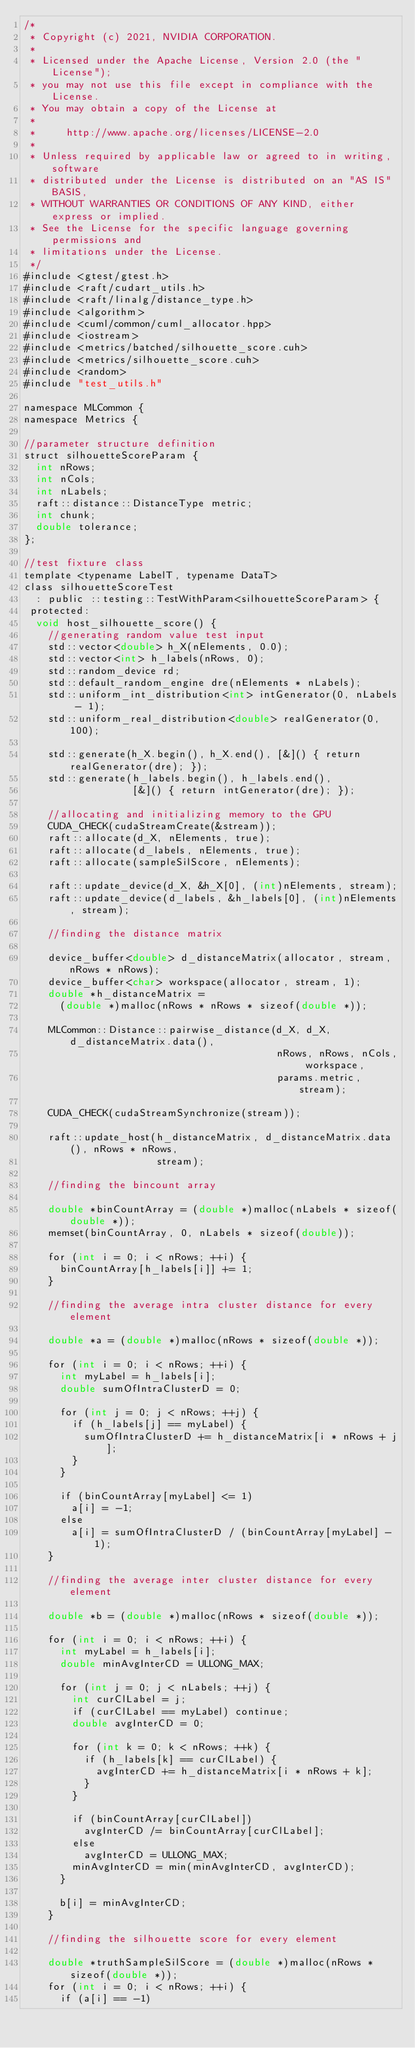Convert code to text. <code><loc_0><loc_0><loc_500><loc_500><_Cuda_>/*
 * Copyright (c) 2021, NVIDIA CORPORATION.
 *
 * Licensed under the Apache License, Version 2.0 (the "License");
 * you may not use this file except in compliance with the License.
 * You may obtain a copy of the License at
 *
 *     http://www.apache.org/licenses/LICENSE-2.0
 *
 * Unless required by applicable law or agreed to in writing, software
 * distributed under the License is distributed on an "AS IS" BASIS,
 * WITHOUT WARRANTIES OR CONDITIONS OF ANY KIND, either express or implied.
 * See the License for the specific language governing permissions and
 * limitations under the License.
 */
#include <gtest/gtest.h>
#include <raft/cudart_utils.h>
#include <raft/linalg/distance_type.h>
#include <algorithm>
#include <cuml/common/cuml_allocator.hpp>
#include <iostream>
#include <metrics/batched/silhouette_score.cuh>
#include <metrics/silhouette_score.cuh>
#include <random>
#include "test_utils.h"

namespace MLCommon {
namespace Metrics {

//parameter structure definition
struct silhouetteScoreParam {
  int nRows;
  int nCols;
  int nLabels;
  raft::distance::DistanceType metric;
  int chunk;
  double tolerance;
};

//test fixture class
template <typename LabelT, typename DataT>
class silhouetteScoreTest
  : public ::testing::TestWithParam<silhouetteScoreParam> {
 protected:
  void host_silhouette_score() {
    //generating random value test input
    std::vector<double> h_X(nElements, 0.0);
    std::vector<int> h_labels(nRows, 0);
    std::random_device rd;
    std::default_random_engine dre(nElements * nLabels);
    std::uniform_int_distribution<int> intGenerator(0, nLabels - 1);
    std::uniform_real_distribution<double> realGenerator(0, 100);

    std::generate(h_X.begin(), h_X.end(), [&]() { return realGenerator(dre); });
    std::generate(h_labels.begin(), h_labels.end(),
                  [&]() { return intGenerator(dre); });

    //allocating and initializing memory to the GPU
    CUDA_CHECK(cudaStreamCreate(&stream));
    raft::allocate(d_X, nElements, true);
    raft::allocate(d_labels, nElements, true);
    raft::allocate(sampleSilScore, nElements);

    raft::update_device(d_X, &h_X[0], (int)nElements, stream);
    raft::update_device(d_labels, &h_labels[0], (int)nElements, stream);

    //finding the distance matrix

    device_buffer<double> d_distanceMatrix(allocator, stream, nRows * nRows);
    device_buffer<char> workspace(allocator, stream, 1);
    double *h_distanceMatrix =
      (double *)malloc(nRows * nRows * sizeof(double *));

    MLCommon::Distance::pairwise_distance(d_X, d_X, d_distanceMatrix.data(),
                                          nRows, nRows, nCols, workspace,
                                          params.metric, stream);

    CUDA_CHECK(cudaStreamSynchronize(stream));

    raft::update_host(h_distanceMatrix, d_distanceMatrix.data(), nRows * nRows,
                      stream);

    //finding the bincount array

    double *binCountArray = (double *)malloc(nLabels * sizeof(double *));
    memset(binCountArray, 0, nLabels * sizeof(double));

    for (int i = 0; i < nRows; ++i) {
      binCountArray[h_labels[i]] += 1;
    }

    //finding the average intra cluster distance for every element

    double *a = (double *)malloc(nRows * sizeof(double *));

    for (int i = 0; i < nRows; ++i) {
      int myLabel = h_labels[i];
      double sumOfIntraClusterD = 0;

      for (int j = 0; j < nRows; ++j) {
        if (h_labels[j] == myLabel) {
          sumOfIntraClusterD += h_distanceMatrix[i * nRows + j];
        }
      }

      if (binCountArray[myLabel] <= 1)
        a[i] = -1;
      else
        a[i] = sumOfIntraClusterD / (binCountArray[myLabel] - 1);
    }

    //finding the average inter cluster distance for every element

    double *b = (double *)malloc(nRows * sizeof(double *));

    for (int i = 0; i < nRows; ++i) {
      int myLabel = h_labels[i];
      double minAvgInterCD = ULLONG_MAX;

      for (int j = 0; j < nLabels; ++j) {
        int curClLabel = j;
        if (curClLabel == myLabel) continue;
        double avgInterCD = 0;

        for (int k = 0; k < nRows; ++k) {
          if (h_labels[k] == curClLabel) {
            avgInterCD += h_distanceMatrix[i * nRows + k];
          }
        }

        if (binCountArray[curClLabel])
          avgInterCD /= binCountArray[curClLabel];
        else
          avgInterCD = ULLONG_MAX;
        minAvgInterCD = min(minAvgInterCD, avgInterCD);
      }

      b[i] = minAvgInterCD;
    }

    //finding the silhouette score for every element

    double *truthSampleSilScore = (double *)malloc(nRows * sizeof(double *));
    for (int i = 0; i < nRows; ++i) {
      if (a[i] == -1)</code> 